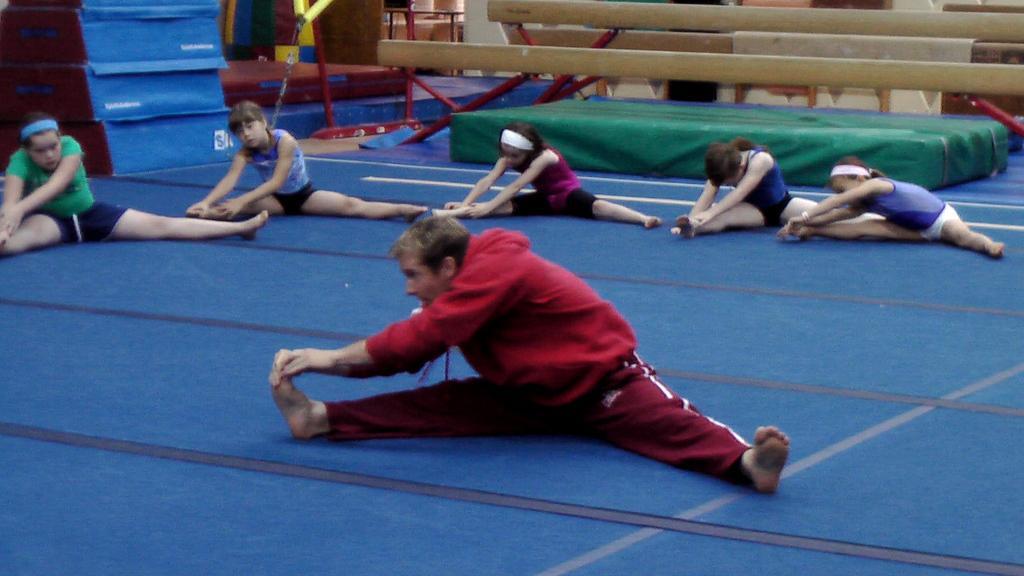Please provide a concise description of this image. In this image there are some people who are doing exercises, at the bottom there is a floor and in the background there are some wooden sticks and some boxes. 